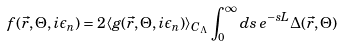<formula> <loc_0><loc_0><loc_500><loc_500>f ( \vec { r } , \Theta , i \epsilon _ { n } ) = 2 \langle g ( \vec { r } , \Theta , i \epsilon _ { n } ) \rangle _ { C _ { \Lambda } } \int _ { 0 } ^ { \infty } d s \, e ^ { - s L } \Delta ( \vec { r } , \Theta )</formula> 